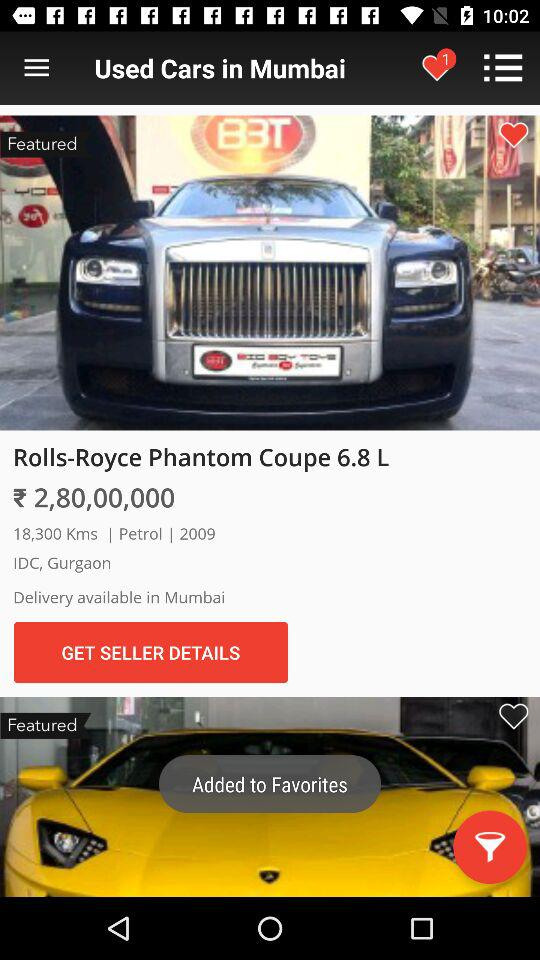How many kilometers has the car driven? The car has driven 18,300 kilometers. 